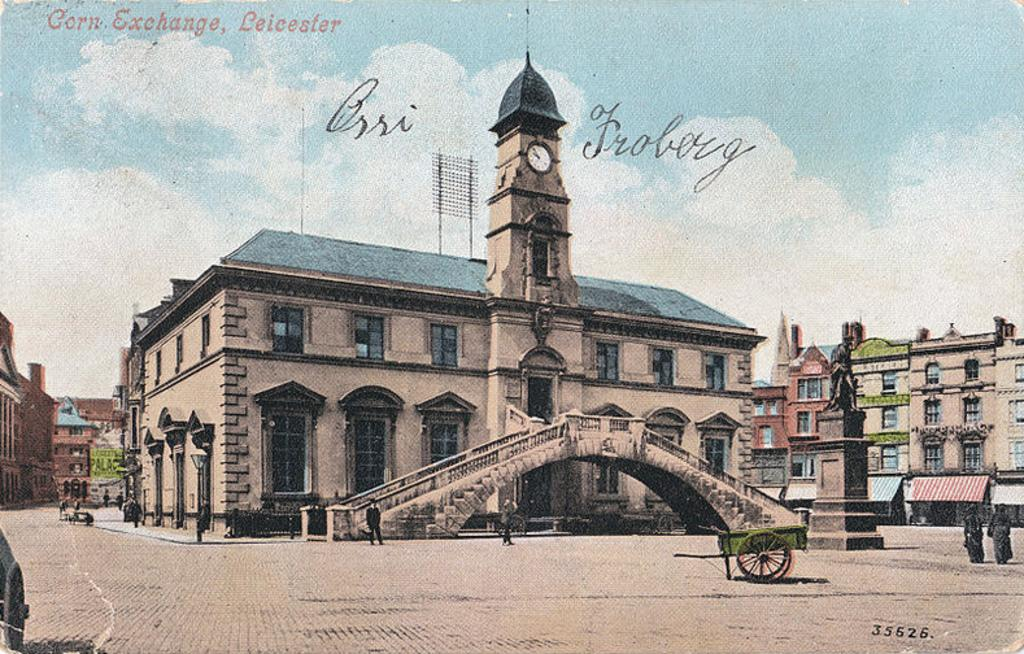What is the main object in the image? There is a wheel cart on a surface in the image. Are there any people in the image? Yes, there are persons in the image. What other notable object can be seen in the image? There is a statue in the image. What can be seen in the background of the image? There are buildings and the sky visible in the background of the image. Is there any text present in the image? Yes, there is text at the top of the image. How many rabbits are hopping around the wheel cart in the image? There are no rabbits present in the image. Is there a source of water visible near the wheel cart in the image? There is no water source visible near the wheel cart in the image. 